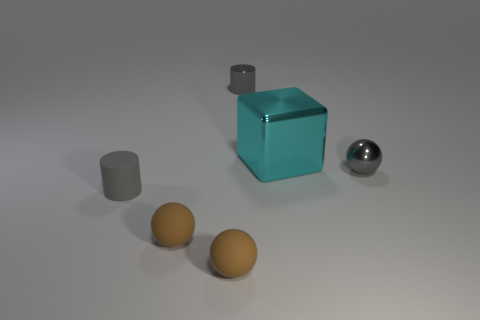Is there any other thing that is the same size as the cyan shiny thing?
Provide a succinct answer. No. Is the shape of the big cyan thing the same as the gray matte object?
Offer a very short reply. No. The tiny gray shiny object left of the gray ball has what shape?
Give a very brief answer. Cylinder. There is a gray cylinder that is in front of the gray metal object to the left of the big cyan metallic cube; how many gray things are in front of it?
Your answer should be very brief. 0. Is the size of the gray ball the same as the cyan metal cube on the right side of the tiny gray rubber cylinder?
Ensure brevity in your answer.  No. What size is the gray metallic object that is behind the ball right of the big metal block?
Provide a succinct answer. Small. How many brown balls are made of the same material as the big cyan object?
Make the answer very short. 0. Are there any blue matte balls?
Your response must be concise. No. There is a gray thing that is behind the large cyan shiny thing; what size is it?
Make the answer very short. Small. How many other cylinders have the same color as the metal cylinder?
Offer a very short reply. 1. 